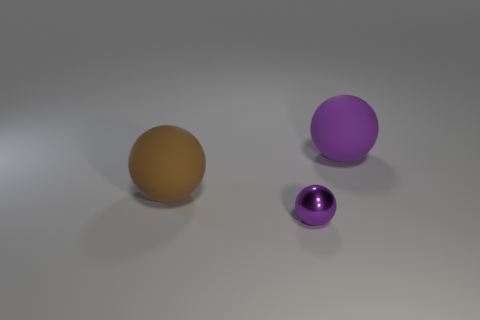Add 2 large spheres. How many objects exist? 5 Subtract all brown balls. How many balls are left? 2 Subtract all big brown balls. How many balls are left? 2 Subtract 3 balls. How many balls are left? 0 Subtract all brown spheres. Subtract all purple cylinders. How many spheres are left? 2 Subtract all gray blocks. How many purple spheres are left? 2 Subtract all rubber balls. Subtract all small things. How many objects are left? 0 Add 1 large purple spheres. How many large purple spheres are left? 2 Add 1 small metal things. How many small metal things exist? 2 Subtract 0 gray blocks. How many objects are left? 3 